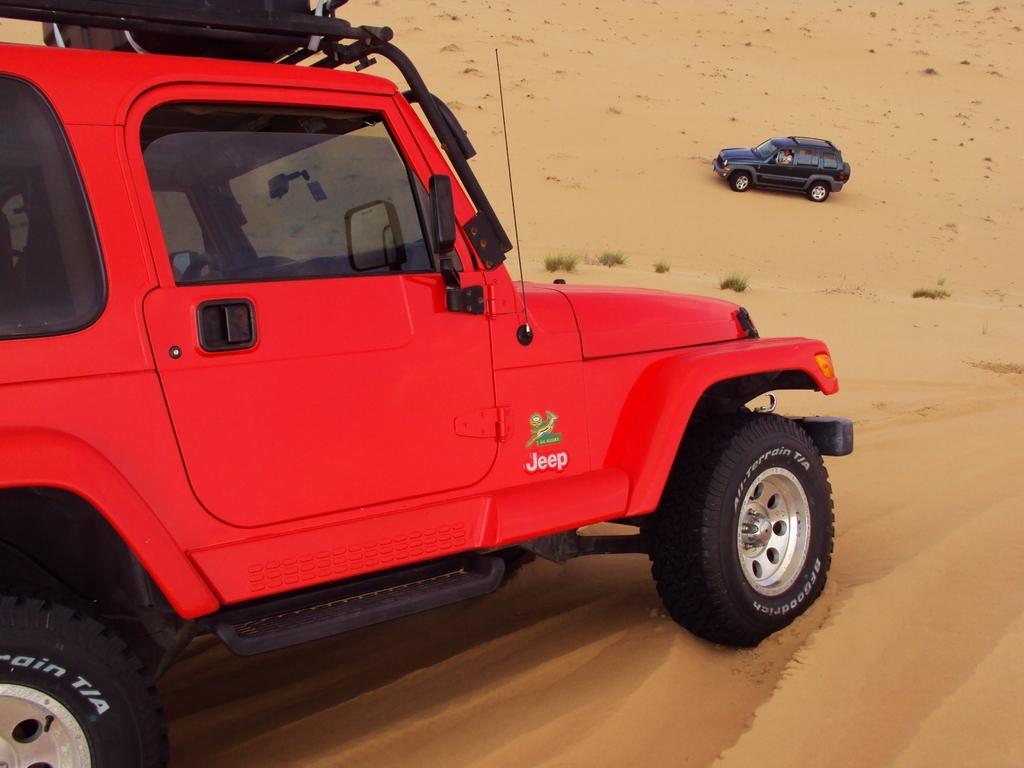Please provide a concise description of this image. In this image, we can see two vehicles are on the sand. Background we can see few plants. Here we can see a person is there inside the vehicle. 